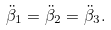Convert formula to latex. <formula><loc_0><loc_0><loc_500><loc_500>\ddot { \beta } _ { 1 } = \ddot { \beta } _ { 2 } = \ddot { \beta } _ { 3 } .</formula> 